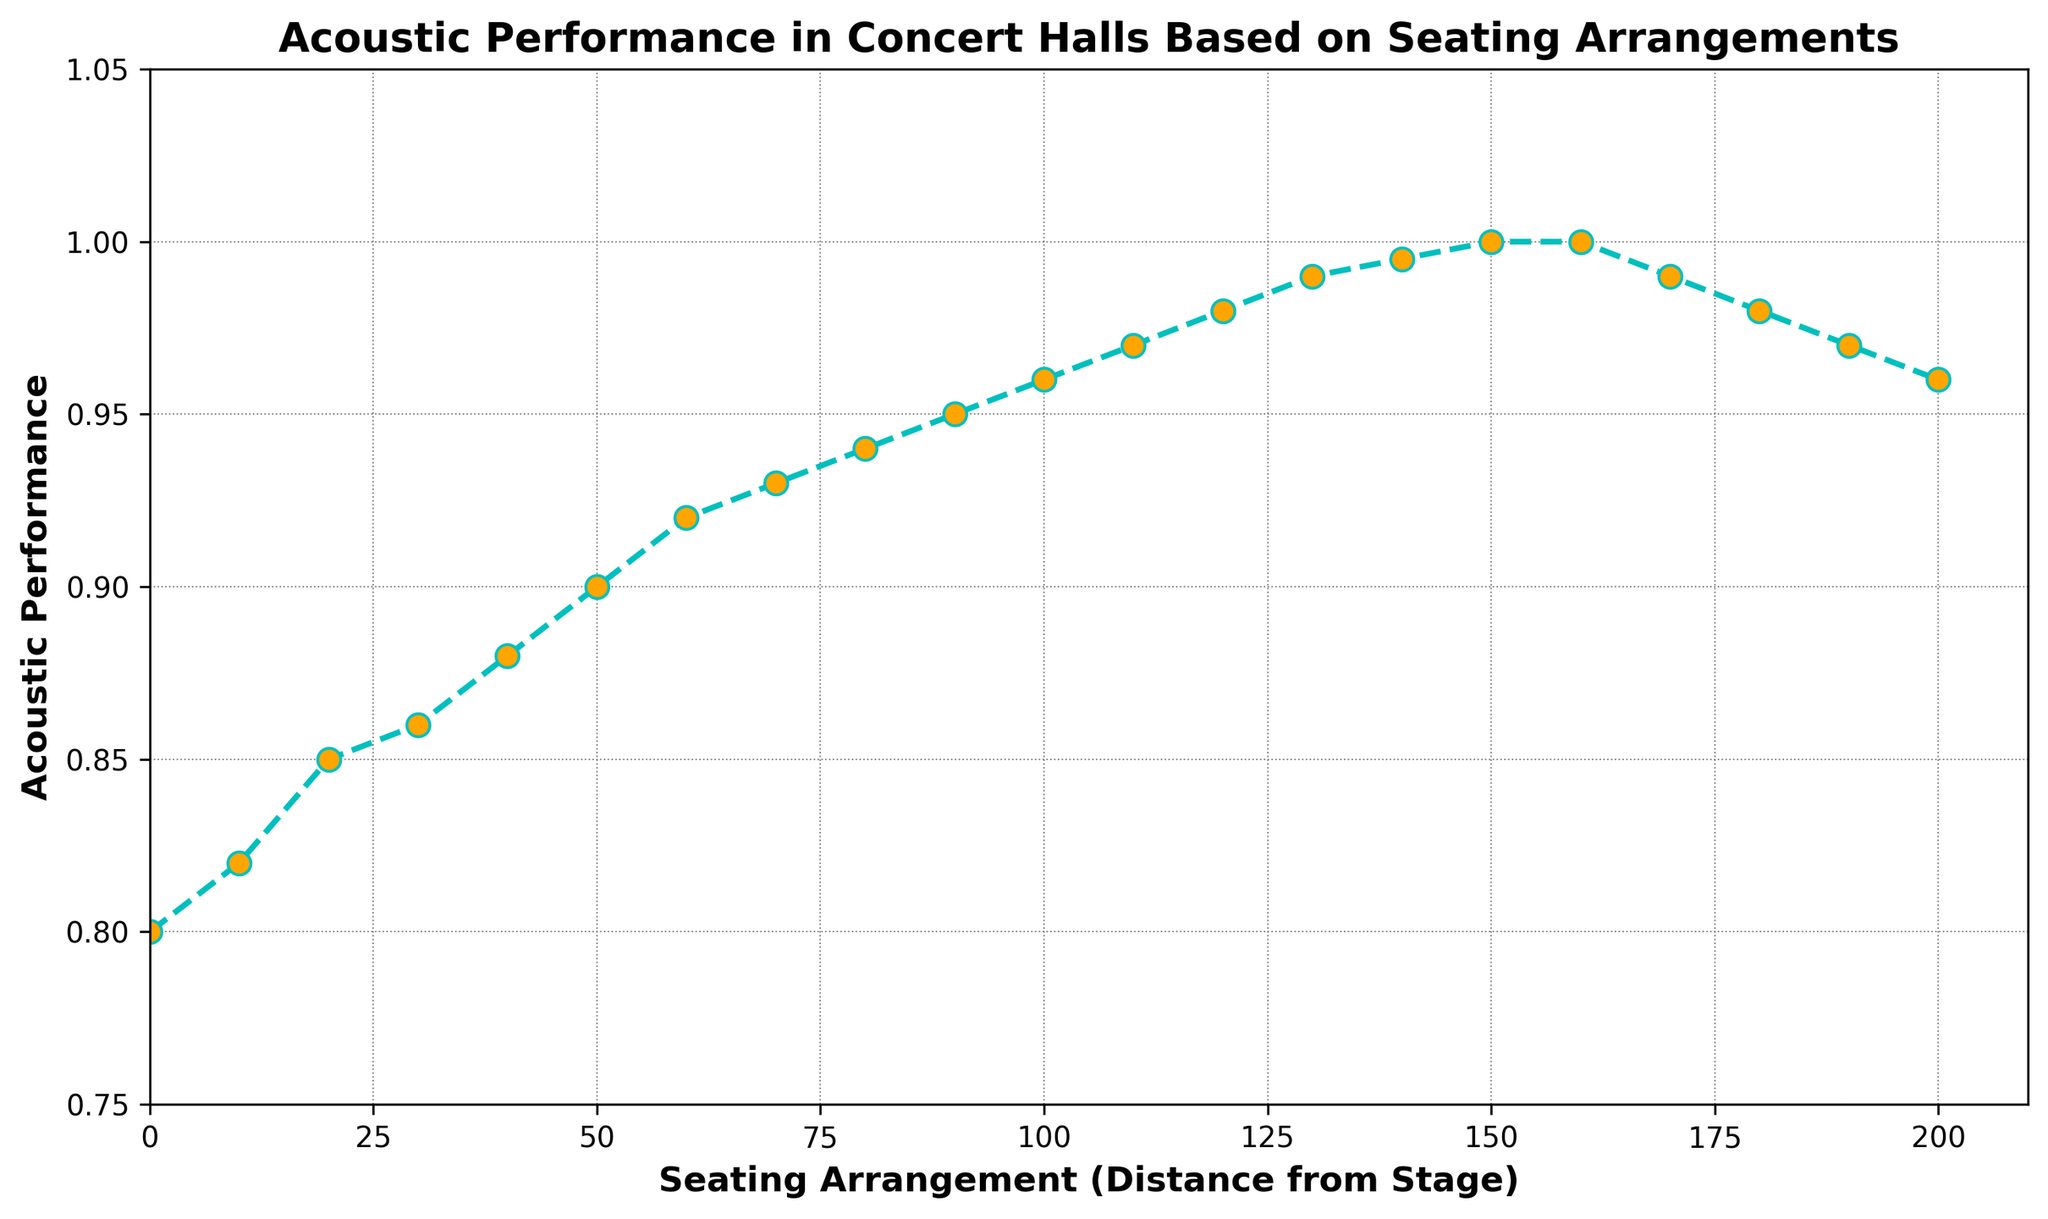What is the highest acoustic performance value in the figure? The highest acoustic performance value can be seen at the peak of the plot where the data points reach their maximum. In this case, it happens at 150 and 160 units from the stage with a value of 1.00.
Answer: 1.00 How does acoustic performance change as the seating arrangement goes from 0 to 50? To determine this, look at the values of acoustic performance at 0, 10, 20, 30, 40, and 50 units. It starts at 0.8, then gradually increases to 0.90 by the time it reaches 50 units.
Answer: It increases gradually What is the difference in acoustic performance between the seating at 130 units and 150 units from the stage? The acoustic performance at 130 units is 0.99, and at 150 units is 1.00. Subtracting these gives 1.00 - 0.99 = 0.01.
Answer: 0.01 Between which seating arrangements does the acoustic performance start to decline? Observing the plot, the performance peaks at 150 and 160 units and begins to decline at 170 units.
Answer: 170 units from the stage At which seating arrangement does the acoustic performance first reach 0.95? By looking at the plot, the performance first reaches 0.95 at 90 units from the stage.
Answer: 90 units If someone sits exactly halfway between 60 and 140 units, what would be the expected acoustic performance at that point? Halfway between 60 and 140 is (60+140)/2 = 100 units. At 100 units, the performance is 0.96.
Answer: 0.96 Which seating arrangement has a higher acoustic performance, 80 or 120 units? The performance at 80 units is 0.94, while at 120 units, it is 0.98. Thus, 120 units have a higher performance.
Answer: 120 units Is the acoustic performance visually increasing, decreasing, or stable between 140 and 170 units? By looking at the plot curve, it's clear that performance is first stable (at the peak around 150 and 160 units) and then starts to decrease at 170 units.
Answer: Stable then decreasing Which seating arrangement shows the steepest rise in acoustic performance? The steepest rise is the portion of the plot with the highest slope. The steep rise appears between 40 and 60 units, where performance quickly increases.
Answer: 40 to 60 units How does the use of color and markers make the plot easier to read? The consistent use of cyan color for the line, orange marker faces, and a dashed line style visually separates data points and makes the trends and individual values more distinguishable. This helps in quickly identifying key changes and maximum values.
Answer: It enhances readability 